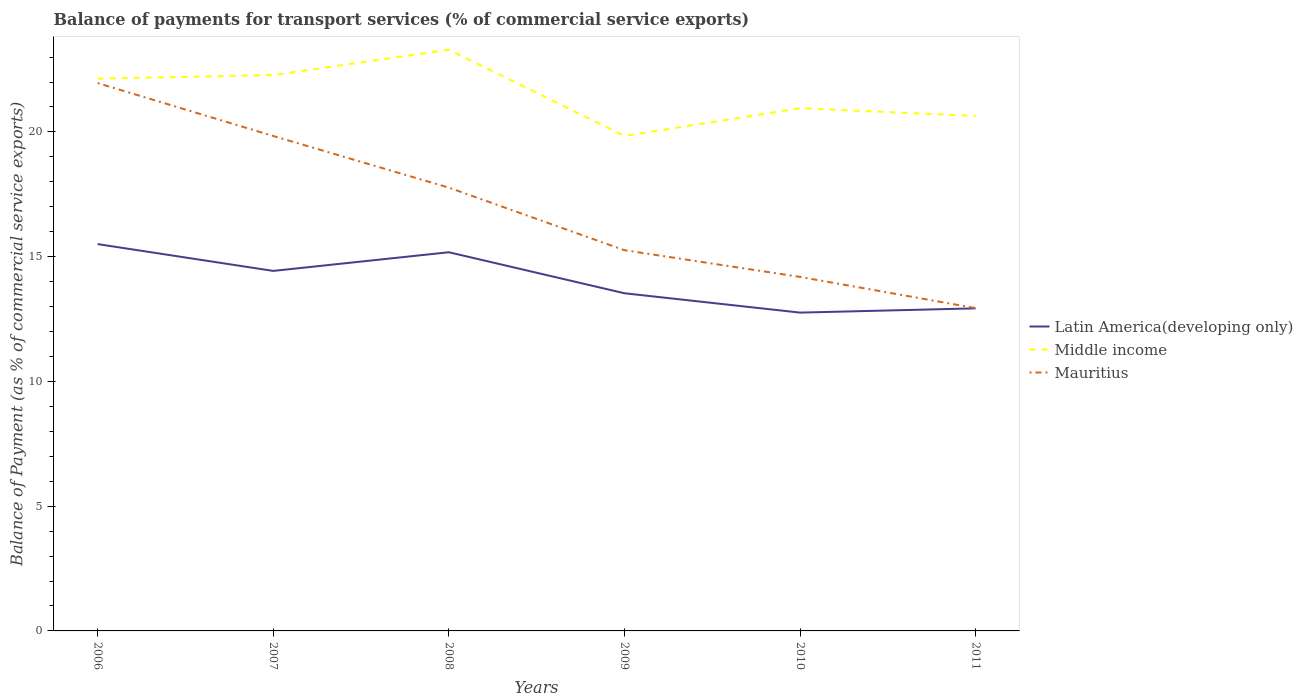How many different coloured lines are there?
Give a very brief answer. 3. Does the line corresponding to Middle income intersect with the line corresponding to Latin America(developing only)?
Your answer should be very brief. No. Across all years, what is the maximum balance of payments for transport services in Middle income?
Keep it short and to the point. 19.84. In which year was the balance of payments for transport services in Latin America(developing only) maximum?
Keep it short and to the point. 2010. What is the total balance of payments for transport services in Middle income in the graph?
Your answer should be compact. -1.02. What is the difference between the highest and the second highest balance of payments for transport services in Mauritius?
Your response must be concise. 9.02. How many lines are there?
Give a very brief answer. 3. Are the values on the major ticks of Y-axis written in scientific E-notation?
Make the answer very short. No. Does the graph contain any zero values?
Offer a very short reply. No. How are the legend labels stacked?
Your answer should be very brief. Vertical. What is the title of the graph?
Your response must be concise. Balance of payments for transport services (% of commercial service exports). What is the label or title of the X-axis?
Provide a short and direct response. Years. What is the label or title of the Y-axis?
Offer a terse response. Balance of Payment (as % of commercial service exports). What is the Balance of Payment (as % of commercial service exports) in Latin America(developing only) in 2006?
Give a very brief answer. 15.5. What is the Balance of Payment (as % of commercial service exports) in Middle income in 2006?
Provide a succinct answer. 22.14. What is the Balance of Payment (as % of commercial service exports) in Mauritius in 2006?
Your answer should be very brief. 21.96. What is the Balance of Payment (as % of commercial service exports) in Latin America(developing only) in 2007?
Offer a very short reply. 14.43. What is the Balance of Payment (as % of commercial service exports) in Middle income in 2007?
Keep it short and to the point. 22.28. What is the Balance of Payment (as % of commercial service exports) of Mauritius in 2007?
Provide a short and direct response. 19.84. What is the Balance of Payment (as % of commercial service exports) of Latin America(developing only) in 2008?
Provide a short and direct response. 15.18. What is the Balance of Payment (as % of commercial service exports) in Middle income in 2008?
Your answer should be very brief. 23.3. What is the Balance of Payment (as % of commercial service exports) in Mauritius in 2008?
Offer a terse response. 17.77. What is the Balance of Payment (as % of commercial service exports) of Latin America(developing only) in 2009?
Ensure brevity in your answer.  13.53. What is the Balance of Payment (as % of commercial service exports) of Middle income in 2009?
Give a very brief answer. 19.84. What is the Balance of Payment (as % of commercial service exports) of Mauritius in 2009?
Offer a terse response. 15.26. What is the Balance of Payment (as % of commercial service exports) in Latin America(developing only) in 2010?
Your answer should be compact. 12.76. What is the Balance of Payment (as % of commercial service exports) in Middle income in 2010?
Your answer should be very brief. 20.95. What is the Balance of Payment (as % of commercial service exports) of Mauritius in 2010?
Make the answer very short. 14.19. What is the Balance of Payment (as % of commercial service exports) of Latin America(developing only) in 2011?
Your answer should be very brief. 12.93. What is the Balance of Payment (as % of commercial service exports) of Middle income in 2011?
Your response must be concise. 20.64. What is the Balance of Payment (as % of commercial service exports) of Mauritius in 2011?
Offer a terse response. 12.94. Across all years, what is the maximum Balance of Payment (as % of commercial service exports) in Latin America(developing only)?
Your answer should be very brief. 15.5. Across all years, what is the maximum Balance of Payment (as % of commercial service exports) of Middle income?
Offer a terse response. 23.3. Across all years, what is the maximum Balance of Payment (as % of commercial service exports) in Mauritius?
Provide a succinct answer. 21.96. Across all years, what is the minimum Balance of Payment (as % of commercial service exports) in Latin America(developing only)?
Provide a short and direct response. 12.76. Across all years, what is the minimum Balance of Payment (as % of commercial service exports) in Middle income?
Ensure brevity in your answer.  19.84. Across all years, what is the minimum Balance of Payment (as % of commercial service exports) of Mauritius?
Your response must be concise. 12.94. What is the total Balance of Payment (as % of commercial service exports) of Latin America(developing only) in the graph?
Ensure brevity in your answer.  84.34. What is the total Balance of Payment (as % of commercial service exports) of Middle income in the graph?
Provide a succinct answer. 129.15. What is the total Balance of Payment (as % of commercial service exports) in Mauritius in the graph?
Your answer should be compact. 101.95. What is the difference between the Balance of Payment (as % of commercial service exports) of Latin America(developing only) in 2006 and that in 2007?
Provide a short and direct response. 1.07. What is the difference between the Balance of Payment (as % of commercial service exports) in Middle income in 2006 and that in 2007?
Offer a very short reply. -0.14. What is the difference between the Balance of Payment (as % of commercial service exports) of Mauritius in 2006 and that in 2007?
Offer a very short reply. 2.12. What is the difference between the Balance of Payment (as % of commercial service exports) in Latin America(developing only) in 2006 and that in 2008?
Offer a very short reply. 0.33. What is the difference between the Balance of Payment (as % of commercial service exports) in Middle income in 2006 and that in 2008?
Your answer should be very brief. -1.16. What is the difference between the Balance of Payment (as % of commercial service exports) in Mauritius in 2006 and that in 2008?
Offer a terse response. 4.19. What is the difference between the Balance of Payment (as % of commercial service exports) of Latin America(developing only) in 2006 and that in 2009?
Make the answer very short. 1.97. What is the difference between the Balance of Payment (as % of commercial service exports) of Middle income in 2006 and that in 2009?
Make the answer very short. 2.29. What is the difference between the Balance of Payment (as % of commercial service exports) of Mauritius in 2006 and that in 2009?
Your answer should be compact. 6.7. What is the difference between the Balance of Payment (as % of commercial service exports) of Latin America(developing only) in 2006 and that in 2010?
Keep it short and to the point. 2.75. What is the difference between the Balance of Payment (as % of commercial service exports) in Middle income in 2006 and that in 2010?
Your answer should be compact. 1.19. What is the difference between the Balance of Payment (as % of commercial service exports) in Mauritius in 2006 and that in 2010?
Your answer should be very brief. 7.77. What is the difference between the Balance of Payment (as % of commercial service exports) in Latin America(developing only) in 2006 and that in 2011?
Provide a succinct answer. 2.58. What is the difference between the Balance of Payment (as % of commercial service exports) of Middle income in 2006 and that in 2011?
Provide a succinct answer. 1.49. What is the difference between the Balance of Payment (as % of commercial service exports) in Mauritius in 2006 and that in 2011?
Your answer should be very brief. 9.02. What is the difference between the Balance of Payment (as % of commercial service exports) in Latin America(developing only) in 2007 and that in 2008?
Your answer should be compact. -0.75. What is the difference between the Balance of Payment (as % of commercial service exports) of Middle income in 2007 and that in 2008?
Make the answer very short. -1.02. What is the difference between the Balance of Payment (as % of commercial service exports) in Mauritius in 2007 and that in 2008?
Your response must be concise. 2.07. What is the difference between the Balance of Payment (as % of commercial service exports) of Latin America(developing only) in 2007 and that in 2009?
Provide a short and direct response. 0.9. What is the difference between the Balance of Payment (as % of commercial service exports) in Middle income in 2007 and that in 2009?
Make the answer very short. 2.44. What is the difference between the Balance of Payment (as % of commercial service exports) in Mauritius in 2007 and that in 2009?
Give a very brief answer. 4.58. What is the difference between the Balance of Payment (as % of commercial service exports) of Latin America(developing only) in 2007 and that in 2010?
Provide a short and direct response. 1.67. What is the difference between the Balance of Payment (as % of commercial service exports) of Middle income in 2007 and that in 2010?
Offer a terse response. 1.33. What is the difference between the Balance of Payment (as % of commercial service exports) of Mauritius in 2007 and that in 2010?
Offer a very short reply. 5.65. What is the difference between the Balance of Payment (as % of commercial service exports) in Latin America(developing only) in 2007 and that in 2011?
Offer a terse response. 1.5. What is the difference between the Balance of Payment (as % of commercial service exports) in Middle income in 2007 and that in 2011?
Make the answer very short. 1.64. What is the difference between the Balance of Payment (as % of commercial service exports) in Mauritius in 2007 and that in 2011?
Provide a short and direct response. 6.9. What is the difference between the Balance of Payment (as % of commercial service exports) in Latin America(developing only) in 2008 and that in 2009?
Make the answer very short. 1.64. What is the difference between the Balance of Payment (as % of commercial service exports) of Middle income in 2008 and that in 2009?
Make the answer very short. 3.45. What is the difference between the Balance of Payment (as % of commercial service exports) of Mauritius in 2008 and that in 2009?
Give a very brief answer. 2.51. What is the difference between the Balance of Payment (as % of commercial service exports) in Latin America(developing only) in 2008 and that in 2010?
Your answer should be compact. 2.42. What is the difference between the Balance of Payment (as % of commercial service exports) in Middle income in 2008 and that in 2010?
Offer a very short reply. 2.34. What is the difference between the Balance of Payment (as % of commercial service exports) in Mauritius in 2008 and that in 2010?
Your response must be concise. 3.58. What is the difference between the Balance of Payment (as % of commercial service exports) of Latin America(developing only) in 2008 and that in 2011?
Your answer should be very brief. 2.25. What is the difference between the Balance of Payment (as % of commercial service exports) of Middle income in 2008 and that in 2011?
Offer a terse response. 2.65. What is the difference between the Balance of Payment (as % of commercial service exports) of Mauritius in 2008 and that in 2011?
Provide a short and direct response. 4.83. What is the difference between the Balance of Payment (as % of commercial service exports) of Latin America(developing only) in 2009 and that in 2010?
Give a very brief answer. 0.78. What is the difference between the Balance of Payment (as % of commercial service exports) of Middle income in 2009 and that in 2010?
Your response must be concise. -1.11. What is the difference between the Balance of Payment (as % of commercial service exports) in Mauritius in 2009 and that in 2010?
Your answer should be very brief. 1.07. What is the difference between the Balance of Payment (as % of commercial service exports) of Latin America(developing only) in 2009 and that in 2011?
Provide a succinct answer. 0.6. What is the difference between the Balance of Payment (as % of commercial service exports) of Middle income in 2009 and that in 2011?
Ensure brevity in your answer.  -0.8. What is the difference between the Balance of Payment (as % of commercial service exports) of Mauritius in 2009 and that in 2011?
Make the answer very short. 2.32. What is the difference between the Balance of Payment (as % of commercial service exports) of Latin America(developing only) in 2010 and that in 2011?
Make the answer very short. -0.17. What is the difference between the Balance of Payment (as % of commercial service exports) of Middle income in 2010 and that in 2011?
Give a very brief answer. 0.31. What is the difference between the Balance of Payment (as % of commercial service exports) of Mauritius in 2010 and that in 2011?
Provide a short and direct response. 1.25. What is the difference between the Balance of Payment (as % of commercial service exports) of Latin America(developing only) in 2006 and the Balance of Payment (as % of commercial service exports) of Middle income in 2007?
Give a very brief answer. -6.78. What is the difference between the Balance of Payment (as % of commercial service exports) in Latin America(developing only) in 2006 and the Balance of Payment (as % of commercial service exports) in Mauritius in 2007?
Provide a short and direct response. -4.33. What is the difference between the Balance of Payment (as % of commercial service exports) in Middle income in 2006 and the Balance of Payment (as % of commercial service exports) in Mauritius in 2007?
Your response must be concise. 2.3. What is the difference between the Balance of Payment (as % of commercial service exports) in Latin America(developing only) in 2006 and the Balance of Payment (as % of commercial service exports) in Middle income in 2008?
Provide a short and direct response. -7.79. What is the difference between the Balance of Payment (as % of commercial service exports) in Latin America(developing only) in 2006 and the Balance of Payment (as % of commercial service exports) in Mauritius in 2008?
Offer a terse response. -2.26. What is the difference between the Balance of Payment (as % of commercial service exports) of Middle income in 2006 and the Balance of Payment (as % of commercial service exports) of Mauritius in 2008?
Your answer should be very brief. 4.37. What is the difference between the Balance of Payment (as % of commercial service exports) in Latin America(developing only) in 2006 and the Balance of Payment (as % of commercial service exports) in Middle income in 2009?
Offer a very short reply. -4.34. What is the difference between the Balance of Payment (as % of commercial service exports) of Latin America(developing only) in 2006 and the Balance of Payment (as % of commercial service exports) of Mauritius in 2009?
Your answer should be very brief. 0.24. What is the difference between the Balance of Payment (as % of commercial service exports) of Middle income in 2006 and the Balance of Payment (as % of commercial service exports) of Mauritius in 2009?
Offer a very short reply. 6.88. What is the difference between the Balance of Payment (as % of commercial service exports) of Latin America(developing only) in 2006 and the Balance of Payment (as % of commercial service exports) of Middle income in 2010?
Provide a short and direct response. -5.45. What is the difference between the Balance of Payment (as % of commercial service exports) of Latin America(developing only) in 2006 and the Balance of Payment (as % of commercial service exports) of Mauritius in 2010?
Provide a short and direct response. 1.32. What is the difference between the Balance of Payment (as % of commercial service exports) of Middle income in 2006 and the Balance of Payment (as % of commercial service exports) of Mauritius in 2010?
Your answer should be very brief. 7.95. What is the difference between the Balance of Payment (as % of commercial service exports) of Latin America(developing only) in 2006 and the Balance of Payment (as % of commercial service exports) of Middle income in 2011?
Your answer should be very brief. -5.14. What is the difference between the Balance of Payment (as % of commercial service exports) of Latin America(developing only) in 2006 and the Balance of Payment (as % of commercial service exports) of Mauritius in 2011?
Ensure brevity in your answer.  2.57. What is the difference between the Balance of Payment (as % of commercial service exports) in Middle income in 2006 and the Balance of Payment (as % of commercial service exports) in Mauritius in 2011?
Provide a short and direct response. 9.2. What is the difference between the Balance of Payment (as % of commercial service exports) of Latin America(developing only) in 2007 and the Balance of Payment (as % of commercial service exports) of Middle income in 2008?
Your response must be concise. -8.87. What is the difference between the Balance of Payment (as % of commercial service exports) of Latin America(developing only) in 2007 and the Balance of Payment (as % of commercial service exports) of Mauritius in 2008?
Provide a succinct answer. -3.34. What is the difference between the Balance of Payment (as % of commercial service exports) of Middle income in 2007 and the Balance of Payment (as % of commercial service exports) of Mauritius in 2008?
Offer a very short reply. 4.51. What is the difference between the Balance of Payment (as % of commercial service exports) in Latin America(developing only) in 2007 and the Balance of Payment (as % of commercial service exports) in Middle income in 2009?
Provide a succinct answer. -5.41. What is the difference between the Balance of Payment (as % of commercial service exports) in Latin America(developing only) in 2007 and the Balance of Payment (as % of commercial service exports) in Mauritius in 2009?
Ensure brevity in your answer.  -0.83. What is the difference between the Balance of Payment (as % of commercial service exports) of Middle income in 2007 and the Balance of Payment (as % of commercial service exports) of Mauritius in 2009?
Your answer should be very brief. 7.02. What is the difference between the Balance of Payment (as % of commercial service exports) of Latin America(developing only) in 2007 and the Balance of Payment (as % of commercial service exports) of Middle income in 2010?
Your response must be concise. -6.52. What is the difference between the Balance of Payment (as % of commercial service exports) in Latin America(developing only) in 2007 and the Balance of Payment (as % of commercial service exports) in Mauritius in 2010?
Your response must be concise. 0.24. What is the difference between the Balance of Payment (as % of commercial service exports) in Middle income in 2007 and the Balance of Payment (as % of commercial service exports) in Mauritius in 2010?
Offer a terse response. 8.09. What is the difference between the Balance of Payment (as % of commercial service exports) in Latin America(developing only) in 2007 and the Balance of Payment (as % of commercial service exports) in Middle income in 2011?
Your response must be concise. -6.21. What is the difference between the Balance of Payment (as % of commercial service exports) in Latin America(developing only) in 2007 and the Balance of Payment (as % of commercial service exports) in Mauritius in 2011?
Give a very brief answer. 1.49. What is the difference between the Balance of Payment (as % of commercial service exports) of Middle income in 2007 and the Balance of Payment (as % of commercial service exports) of Mauritius in 2011?
Provide a short and direct response. 9.34. What is the difference between the Balance of Payment (as % of commercial service exports) in Latin America(developing only) in 2008 and the Balance of Payment (as % of commercial service exports) in Middle income in 2009?
Offer a very short reply. -4.66. What is the difference between the Balance of Payment (as % of commercial service exports) in Latin America(developing only) in 2008 and the Balance of Payment (as % of commercial service exports) in Mauritius in 2009?
Your response must be concise. -0.08. What is the difference between the Balance of Payment (as % of commercial service exports) in Middle income in 2008 and the Balance of Payment (as % of commercial service exports) in Mauritius in 2009?
Offer a terse response. 8.04. What is the difference between the Balance of Payment (as % of commercial service exports) of Latin America(developing only) in 2008 and the Balance of Payment (as % of commercial service exports) of Middle income in 2010?
Your answer should be very brief. -5.77. What is the difference between the Balance of Payment (as % of commercial service exports) in Latin America(developing only) in 2008 and the Balance of Payment (as % of commercial service exports) in Mauritius in 2010?
Provide a short and direct response. 0.99. What is the difference between the Balance of Payment (as % of commercial service exports) in Middle income in 2008 and the Balance of Payment (as % of commercial service exports) in Mauritius in 2010?
Your answer should be very brief. 9.11. What is the difference between the Balance of Payment (as % of commercial service exports) in Latin America(developing only) in 2008 and the Balance of Payment (as % of commercial service exports) in Middle income in 2011?
Your answer should be very brief. -5.46. What is the difference between the Balance of Payment (as % of commercial service exports) of Latin America(developing only) in 2008 and the Balance of Payment (as % of commercial service exports) of Mauritius in 2011?
Offer a very short reply. 2.24. What is the difference between the Balance of Payment (as % of commercial service exports) in Middle income in 2008 and the Balance of Payment (as % of commercial service exports) in Mauritius in 2011?
Offer a very short reply. 10.36. What is the difference between the Balance of Payment (as % of commercial service exports) of Latin America(developing only) in 2009 and the Balance of Payment (as % of commercial service exports) of Middle income in 2010?
Ensure brevity in your answer.  -7.42. What is the difference between the Balance of Payment (as % of commercial service exports) of Latin America(developing only) in 2009 and the Balance of Payment (as % of commercial service exports) of Mauritius in 2010?
Make the answer very short. -0.65. What is the difference between the Balance of Payment (as % of commercial service exports) in Middle income in 2009 and the Balance of Payment (as % of commercial service exports) in Mauritius in 2010?
Ensure brevity in your answer.  5.65. What is the difference between the Balance of Payment (as % of commercial service exports) of Latin America(developing only) in 2009 and the Balance of Payment (as % of commercial service exports) of Middle income in 2011?
Keep it short and to the point. -7.11. What is the difference between the Balance of Payment (as % of commercial service exports) in Latin America(developing only) in 2009 and the Balance of Payment (as % of commercial service exports) in Mauritius in 2011?
Your response must be concise. 0.6. What is the difference between the Balance of Payment (as % of commercial service exports) in Middle income in 2009 and the Balance of Payment (as % of commercial service exports) in Mauritius in 2011?
Make the answer very short. 6.9. What is the difference between the Balance of Payment (as % of commercial service exports) of Latin America(developing only) in 2010 and the Balance of Payment (as % of commercial service exports) of Middle income in 2011?
Your response must be concise. -7.88. What is the difference between the Balance of Payment (as % of commercial service exports) of Latin America(developing only) in 2010 and the Balance of Payment (as % of commercial service exports) of Mauritius in 2011?
Provide a short and direct response. -0.18. What is the difference between the Balance of Payment (as % of commercial service exports) in Middle income in 2010 and the Balance of Payment (as % of commercial service exports) in Mauritius in 2011?
Make the answer very short. 8.01. What is the average Balance of Payment (as % of commercial service exports) of Latin America(developing only) per year?
Provide a short and direct response. 14.06. What is the average Balance of Payment (as % of commercial service exports) in Middle income per year?
Your response must be concise. 21.52. What is the average Balance of Payment (as % of commercial service exports) in Mauritius per year?
Provide a succinct answer. 16.99. In the year 2006, what is the difference between the Balance of Payment (as % of commercial service exports) in Latin America(developing only) and Balance of Payment (as % of commercial service exports) in Middle income?
Offer a very short reply. -6.63. In the year 2006, what is the difference between the Balance of Payment (as % of commercial service exports) in Latin America(developing only) and Balance of Payment (as % of commercial service exports) in Mauritius?
Give a very brief answer. -6.45. In the year 2006, what is the difference between the Balance of Payment (as % of commercial service exports) in Middle income and Balance of Payment (as % of commercial service exports) in Mauritius?
Keep it short and to the point. 0.18. In the year 2007, what is the difference between the Balance of Payment (as % of commercial service exports) in Latin America(developing only) and Balance of Payment (as % of commercial service exports) in Middle income?
Your response must be concise. -7.85. In the year 2007, what is the difference between the Balance of Payment (as % of commercial service exports) of Latin America(developing only) and Balance of Payment (as % of commercial service exports) of Mauritius?
Ensure brevity in your answer.  -5.41. In the year 2007, what is the difference between the Balance of Payment (as % of commercial service exports) of Middle income and Balance of Payment (as % of commercial service exports) of Mauritius?
Keep it short and to the point. 2.44. In the year 2008, what is the difference between the Balance of Payment (as % of commercial service exports) in Latin America(developing only) and Balance of Payment (as % of commercial service exports) in Middle income?
Your response must be concise. -8.12. In the year 2008, what is the difference between the Balance of Payment (as % of commercial service exports) of Latin America(developing only) and Balance of Payment (as % of commercial service exports) of Mauritius?
Provide a succinct answer. -2.59. In the year 2008, what is the difference between the Balance of Payment (as % of commercial service exports) in Middle income and Balance of Payment (as % of commercial service exports) in Mauritius?
Offer a terse response. 5.53. In the year 2009, what is the difference between the Balance of Payment (as % of commercial service exports) in Latin America(developing only) and Balance of Payment (as % of commercial service exports) in Middle income?
Offer a terse response. -6.31. In the year 2009, what is the difference between the Balance of Payment (as % of commercial service exports) in Latin America(developing only) and Balance of Payment (as % of commercial service exports) in Mauritius?
Provide a short and direct response. -1.73. In the year 2009, what is the difference between the Balance of Payment (as % of commercial service exports) in Middle income and Balance of Payment (as % of commercial service exports) in Mauritius?
Your answer should be compact. 4.58. In the year 2010, what is the difference between the Balance of Payment (as % of commercial service exports) in Latin America(developing only) and Balance of Payment (as % of commercial service exports) in Middle income?
Offer a terse response. -8.19. In the year 2010, what is the difference between the Balance of Payment (as % of commercial service exports) of Latin America(developing only) and Balance of Payment (as % of commercial service exports) of Mauritius?
Keep it short and to the point. -1.43. In the year 2010, what is the difference between the Balance of Payment (as % of commercial service exports) of Middle income and Balance of Payment (as % of commercial service exports) of Mauritius?
Provide a succinct answer. 6.76. In the year 2011, what is the difference between the Balance of Payment (as % of commercial service exports) of Latin America(developing only) and Balance of Payment (as % of commercial service exports) of Middle income?
Offer a very short reply. -7.71. In the year 2011, what is the difference between the Balance of Payment (as % of commercial service exports) of Latin America(developing only) and Balance of Payment (as % of commercial service exports) of Mauritius?
Keep it short and to the point. -0.01. In the year 2011, what is the difference between the Balance of Payment (as % of commercial service exports) of Middle income and Balance of Payment (as % of commercial service exports) of Mauritius?
Keep it short and to the point. 7.7. What is the ratio of the Balance of Payment (as % of commercial service exports) in Latin America(developing only) in 2006 to that in 2007?
Give a very brief answer. 1.07. What is the ratio of the Balance of Payment (as % of commercial service exports) of Mauritius in 2006 to that in 2007?
Your answer should be compact. 1.11. What is the ratio of the Balance of Payment (as % of commercial service exports) of Latin America(developing only) in 2006 to that in 2008?
Your answer should be compact. 1.02. What is the ratio of the Balance of Payment (as % of commercial service exports) of Middle income in 2006 to that in 2008?
Give a very brief answer. 0.95. What is the ratio of the Balance of Payment (as % of commercial service exports) of Mauritius in 2006 to that in 2008?
Offer a very short reply. 1.24. What is the ratio of the Balance of Payment (as % of commercial service exports) of Latin America(developing only) in 2006 to that in 2009?
Keep it short and to the point. 1.15. What is the ratio of the Balance of Payment (as % of commercial service exports) of Middle income in 2006 to that in 2009?
Make the answer very short. 1.12. What is the ratio of the Balance of Payment (as % of commercial service exports) of Mauritius in 2006 to that in 2009?
Keep it short and to the point. 1.44. What is the ratio of the Balance of Payment (as % of commercial service exports) of Latin America(developing only) in 2006 to that in 2010?
Provide a short and direct response. 1.22. What is the ratio of the Balance of Payment (as % of commercial service exports) of Middle income in 2006 to that in 2010?
Your answer should be very brief. 1.06. What is the ratio of the Balance of Payment (as % of commercial service exports) of Mauritius in 2006 to that in 2010?
Provide a short and direct response. 1.55. What is the ratio of the Balance of Payment (as % of commercial service exports) in Latin America(developing only) in 2006 to that in 2011?
Your response must be concise. 1.2. What is the ratio of the Balance of Payment (as % of commercial service exports) of Middle income in 2006 to that in 2011?
Offer a very short reply. 1.07. What is the ratio of the Balance of Payment (as % of commercial service exports) of Mauritius in 2006 to that in 2011?
Ensure brevity in your answer.  1.7. What is the ratio of the Balance of Payment (as % of commercial service exports) of Latin America(developing only) in 2007 to that in 2008?
Offer a terse response. 0.95. What is the ratio of the Balance of Payment (as % of commercial service exports) of Middle income in 2007 to that in 2008?
Offer a terse response. 0.96. What is the ratio of the Balance of Payment (as % of commercial service exports) in Mauritius in 2007 to that in 2008?
Keep it short and to the point. 1.12. What is the ratio of the Balance of Payment (as % of commercial service exports) in Latin America(developing only) in 2007 to that in 2009?
Offer a very short reply. 1.07. What is the ratio of the Balance of Payment (as % of commercial service exports) in Middle income in 2007 to that in 2009?
Offer a very short reply. 1.12. What is the ratio of the Balance of Payment (as % of commercial service exports) in Mauritius in 2007 to that in 2009?
Your answer should be very brief. 1.3. What is the ratio of the Balance of Payment (as % of commercial service exports) in Latin America(developing only) in 2007 to that in 2010?
Your answer should be compact. 1.13. What is the ratio of the Balance of Payment (as % of commercial service exports) in Middle income in 2007 to that in 2010?
Provide a short and direct response. 1.06. What is the ratio of the Balance of Payment (as % of commercial service exports) in Mauritius in 2007 to that in 2010?
Offer a very short reply. 1.4. What is the ratio of the Balance of Payment (as % of commercial service exports) of Latin America(developing only) in 2007 to that in 2011?
Your answer should be very brief. 1.12. What is the ratio of the Balance of Payment (as % of commercial service exports) in Middle income in 2007 to that in 2011?
Provide a short and direct response. 1.08. What is the ratio of the Balance of Payment (as % of commercial service exports) of Mauritius in 2007 to that in 2011?
Your response must be concise. 1.53. What is the ratio of the Balance of Payment (as % of commercial service exports) in Latin America(developing only) in 2008 to that in 2009?
Your answer should be very brief. 1.12. What is the ratio of the Balance of Payment (as % of commercial service exports) of Middle income in 2008 to that in 2009?
Give a very brief answer. 1.17. What is the ratio of the Balance of Payment (as % of commercial service exports) in Mauritius in 2008 to that in 2009?
Give a very brief answer. 1.16. What is the ratio of the Balance of Payment (as % of commercial service exports) of Latin America(developing only) in 2008 to that in 2010?
Provide a succinct answer. 1.19. What is the ratio of the Balance of Payment (as % of commercial service exports) of Middle income in 2008 to that in 2010?
Provide a succinct answer. 1.11. What is the ratio of the Balance of Payment (as % of commercial service exports) of Mauritius in 2008 to that in 2010?
Offer a terse response. 1.25. What is the ratio of the Balance of Payment (as % of commercial service exports) of Latin America(developing only) in 2008 to that in 2011?
Ensure brevity in your answer.  1.17. What is the ratio of the Balance of Payment (as % of commercial service exports) of Middle income in 2008 to that in 2011?
Your answer should be compact. 1.13. What is the ratio of the Balance of Payment (as % of commercial service exports) in Mauritius in 2008 to that in 2011?
Provide a succinct answer. 1.37. What is the ratio of the Balance of Payment (as % of commercial service exports) of Latin America(developing only) in 2009 to that in 2010?
Your response must be concise. 1.06. What is the ratio of the Balance of Payment (as % of commercial service exports) in Middle income in 2009 to that in 2010?
Offer a very short reply. 0.95. What is the ratio of the Balance of Payment (as % of commercial service exports) of Mauritius in 2009 to that in 2010?
Offer a terse response. 1.08. What is the ratio of the Balance of Payment (as % of commercial service exports) of Latin America(developing only) in 2009 to that in 2011?
Give a very brief answer. 1.05. What is the ratio of the Balance of Payment (as % of commercial service exports) of Middle income in 2009 to that in 2011?
Provide a short and direct response. 0.96. What is the ratio of the Balance of Payment (as % of commercial service exports) of Mauritius in 2009 to that in 2011?
Provide a short and direct response. 1.18. What is the ratio of the Balance of Payment (as % of commercial service exports) of Latin America(developing only) in 2010 to that in 2011?
Offer a terse response. 0.99. What is the ratio of the Balance of Payment (as % of commercial service exports) in Middle income in 2010 to that in 2011?
Make the answer very short. 1.01. What is the ratio of the Balance of Payment (as % of commercial service exports) in Mauritius in 2010 to that in 2011?
Keep it short and to the point. 1.1. What is the difference between the highest and the second highest Balance of Payment (as % of commercial service exports) of Latin America(developing only)?
Offer a very short reply. 0.33. What is the difference between the highest and the second highest Balance of Payment (as % of commercial service exports) of Mauritius?
Provide a succinct answer. 2.12. What is the difference between the highest and the lowest Balance of Payment (as % of commercial service exports) of Latin America(developing only)?
Provide a short and direct response. 2.75. What is the difference between the highest and the lowest Balance of Payment (as % of commercial service exports) in Middle income?
Keep it short and to the point. 3.45. What is the difference between the highest and the lowest Balance of Payment (as % of commercial service exports) of Mauritius?
Make the answer very short. 9.02. 